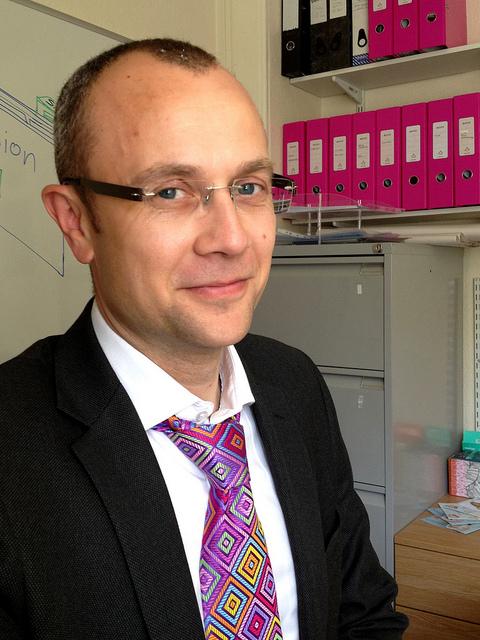What color are his glasses?
Quick response, please. Black. What design does the man's tie have?
Give a very brief answer. Diamonds. Is this person wearing glasses?
Write a very short answer. Yes. Does the man have a beard?
Write a very short answer. No. 